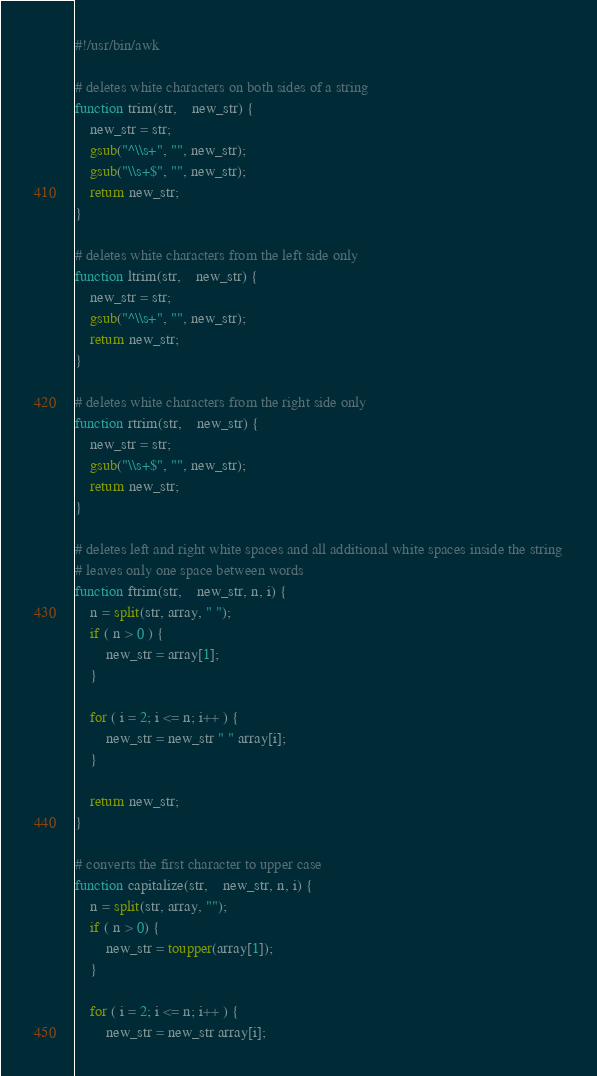Convert code to text. <code><loc_0><loc_0><loc_500><loc_500><_Awk_>#!/usr/bin/awk

# deletes white characters on both sides of a string
function trim(str,    new_str) {
	new_str = str;
	gsub("^\\s+", "", new_str);
	gsub("\\s+$", "", new_str);	
	return new_str;
}

# deletes white characters from the left side only
function ltrim(str,    new_str) {
	new_str = str;
	gsub("^\\s+", "", new_str);
	return new_str;
}

# deletes white characters from the right side only
function rtrim(str,    new_str) {
	new_str = str;
	gsub("\\s+$", "", new_str);
	return new_str;
}

# deletes left and right white spaces and all additional white spaces inside the string
# leaves only one space between words
function ftrim(str,    new_str, n, i) {
	n = split(str, array, " ");
	if ( n > 0 ) {
		new_str = array[1];
	}	

	for ( i = 2; i <= n; i++ ) {
		new_str = new_str " " array[i];
	}

	return new_str;
}

# converts the first character to upper case
function capitalize(str,    new_str, n, i) {
	n = split(str, array, "");
	if ( n > 0) {
		new_str = toupper(array[1]);
	}

	for ( i = 2; i <= n; i++ ) {
		new_str = new_str array[i];</code> 